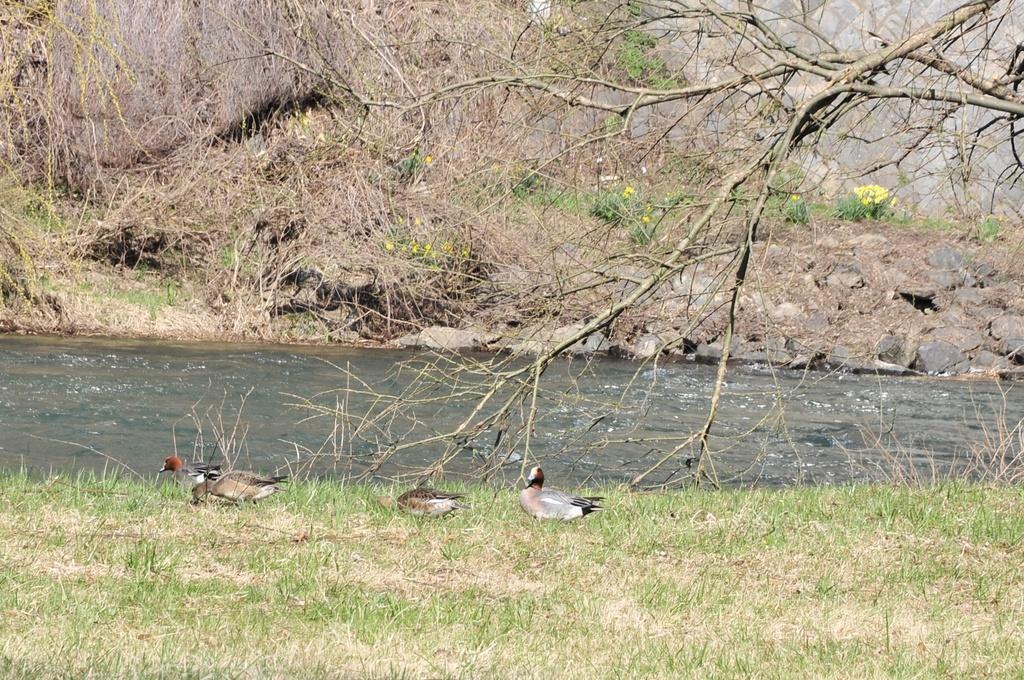How would you summarize this image in a sentence or two? In the picture I can see birds on the ground. In the background I can see the water, the grass, trees and other objects on the ground. 